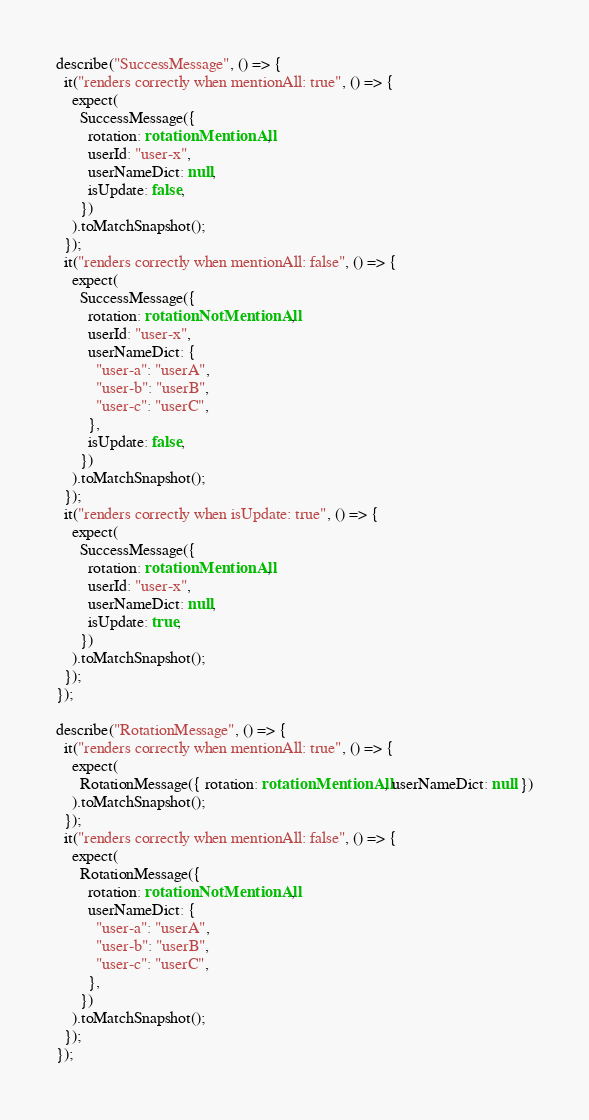Convert code to text. <code><loc_0><loc_0><loc_500><loc_500><_TypeScript_>describe("SuccessMessage", () => {
  it("renders correctly when mentionAll: true", () => {
    expect(
      SuccessMessage({
        rotation: rotationMentionAll,
        userId: "user-x",
        userNameDict: null,
        isUpdate: false,
      })
    ).toMatchSnapshot();
  });
  it("renders correctly when mentionAll: false", () => {
    expect(
      SuccessMessage({
        rotation: rotationNotMentionAll,
        userId: "user-x",
        userNameDict: {
          "user-a": "userA",
          "user-b": "userB",
          "user-c": "userC",
        },
        isUpdate: false,
      })
    ).toMatchSnapshot();
  });
  it("renders correctly when isUpdate: true", () => {
    expect(
      SuccessMessage({
        rotation: rotationMentionAll,
        userId: "user-x",
        userNameDict: null,
        isUpdate: true,
      })
    ).toMatchSnapshot();
  });
});

describe("RotationMessage", () => {
  it("renders correctly when mentionAll: true", () => {
    expect(
      RotationMessage({ rotation: rotationMentionAll, userNameDict: null })
    ).toMatchSnapshot();
  });
  it("renders correctly when mentionAll: false", () => {
    expect(
      RotationMessage({
        rotation: rotationNotMentionAll,
        userNameDict: {
          "user-a": "userA",
          "user-b": "userB",
          "user-c": "userC",
        },
      })
    ).toMatchSnapshot();
  });
});
</code> 